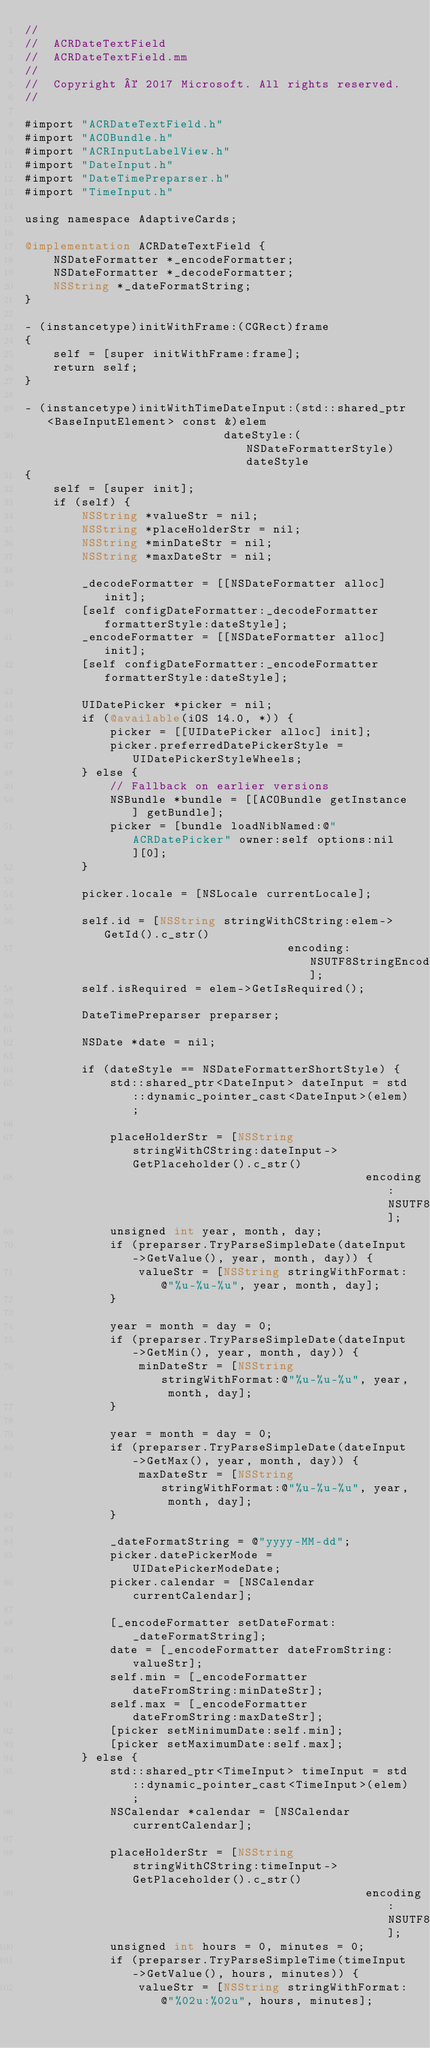<code> <loc_0><loc_0><loc_500><loc_500><_ObjectiveC_>//
//  ACRDateTextField
//  ACRDateTextField.mm
//
//  Copyright © 2017 Microsoft. All rights reserved.
//

#import "ACRDateTextField.h"
#import "ACOBundle.h"
#import "ACRInputLabelView.h"
#import "DateInput.h"
#import "DateTimePreparser.h"
#import "TimeInput.h"

using namespace AdaptiveCards;

@implementation ACRDateTextField {
    NSDateFormatter *_encodeFormatter;
    NSDateFormatter *_decodeFormatter;
    NSString *_dateFormatString;
}

- (instancetype)initWithFrame:(CGRect)frame
{
    self = [super initWithFrame:frame];
    return self;
}

- (instancetype)initWithTimeDateInput:(std::shared_ptr<BaseInputElement> const &)elem
                            dateStyle:(NSDateFormatterStyle)dateStyle
{
    self = [super init];
    if (self) {
        NSString *valueStr = nil;
        NSString *placeHolderStr = nil;
        NSString *minDateStr = nil;
        NSString *maxDateStr = nil;

        _decodeFormatter = [[NSDateFormatter alloc] init];
        [self configDateFormatter:_decodeFormatter formatterStyle:dateStyle];
        _encodeFormatter = [[NSDateFormatter alloc] init];
        [self configDateFormatter:_encodeFormatter formatterStyle:dateStyle];

        UIDatePicker *picker = nil;
        if (@available(iOS 14.0, *)) {
            picker = [[UIDatePicker alloc] init];
            picker.preferredDatePickerStyle = UIDatePickerStyleWheels;
        } else {
            // Fallback on earlier versions
            NSBundle *bundle = [[ACOBundle getInstance] getBundle];
            picker = [bundle loadNibNamed:@"ACRDatePicker" owner:self options:nil][0];
        }

        picker.locale = [NSLocale currentLocale];

        self.id = [NSString stringWithCString:elem->GetId().c_str()
                                     encoding:NSUTF8StringEncoding];
        self.isRequired = elem->GetIsRequired();

        DateTimePreparser preparser;

        NSDate *date = nil;

        if (dateStyle == NSDateFormatterShortStyle) {
            std::shared_ptr<DateInput> dateInput = std::dynamic_pointer_cast<DateInput>(elem);

            placeHolderStr = [NSString stringWithCString:dateInput->GetPlaceholder().c_str()
                                                encoding:NSUTF8StringEncoding];
            unsigned int year, month, day;
            if (preparser.TryParseSimpleDate(dateInput->GetValue(), year, month, day)) {
                valueStr = [NSString stringWithFormat:@"%u-%u-%u", year, month, day];
            }

            year = month = day = 0;
            if (preparser.TryParseSimpleDate(dateInput->GetMin(), year, month, day)) {
                minDateStr = [NSString stringWithFormat:@"%u-%u-%u", year, month, day];
            }

            year = month = day = 0;
            if (preparser.TryParseSimpleDate(dateInput->GetMax(), year, month, day)) {
                maxDateStr = [NSString stringWithFormat:@"%u-%u-%u", year, month, day];
            }

            _dateFormatString = @"yyyy-MM-dd";
            picker.datePickerMode = UIDatePickerModeDate;
            picker.calendar = [NSCalendar currentCalendar];

            [_encodeFormatter setDateFormat:_dateFormatString];
            date = [_encodeFormatter dateFromString:valueStr];
            self.min = [_encodeFormatter dateFromString:minDateStr];
            self.max = [_encodeFormatter dateFromString:maxDateStr];
            [picker setMinimumDate:self.min];
            [picker setMaximumDate:self.max];
        } else {
            std::shared_ptr<TimeInput> timeInput = std::dynamic_pointer_cast<TimeInput>(elem);
            NSCalendar *calendar = [NSCalendar currentCalendar];

            placeHolderStr = [NSString stringWithCString:timeInput->GetPlaceholder().c_str()
                                                encoding:NSUTF8StringEncoding];
            unsigned int hours = 0, minutes = 0;
            if (preparser.TryParseSimpleTime(timeInput->GetValue(), hours, minutes)) {
                valueStr = [NSString stringWithFormat:@"%02u:%02u", hours, minutes];</code> 